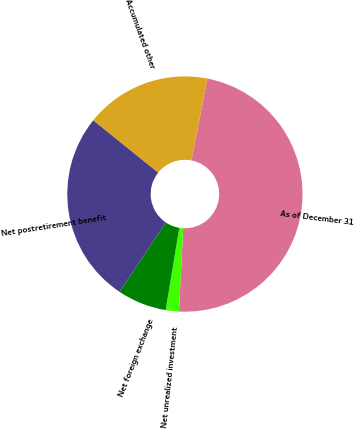<chart> <loc_0><loc_0><loc_500><loc_500><pie_chart><fcel>As of December 31<fcel>Net unrealized investment<fcel>Net foreign exchange<fcel>Net postretirement benefit<fcel>Accumulated other<nl><fcel>47.75%<fcel>1.81%<fcel>6.76%<fcel>26.41%<fcel>17.27%<nl></chart> 